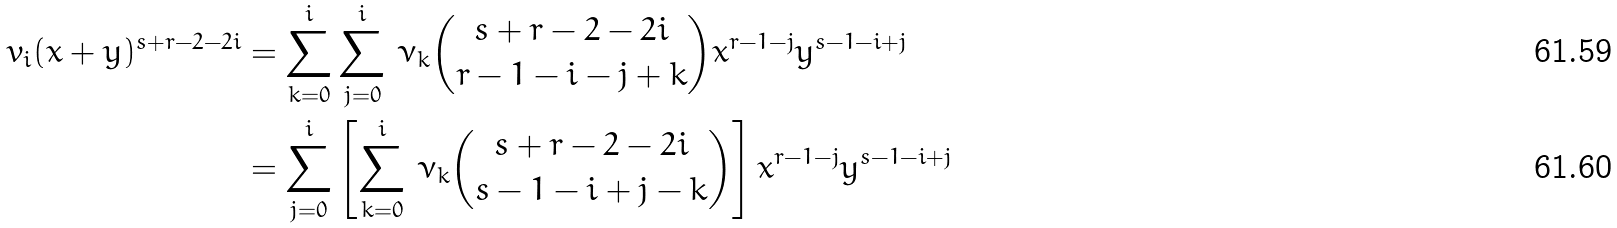Convert formula to latex. <formula><loc_0><loc_0><loc_500><loc_500>v _ { i } ( x + y ) ^ { s + r - 2 - 2 i } & = \sum _ { k = 0 } ^ { i } \sum _ { j = 0 } ^ { i } \, \nu _ { k } \binom { s + r - 2 - 2 i } { r - 1 - i - j + k } x ^ { r - 1 - j } y ^ { s - 1 - i + j } \\ & = \sum _ { j = 0 } ^ { i } \left [ \sum _ { k = 0 } ^ { i } \, \nu _ { k } \binom { s + r - 2 - 2 i } { s - 1 - i + j - k } \right ] x ^ { r - 1 - j } y ^ { s - 1 - i + j }</formula> 